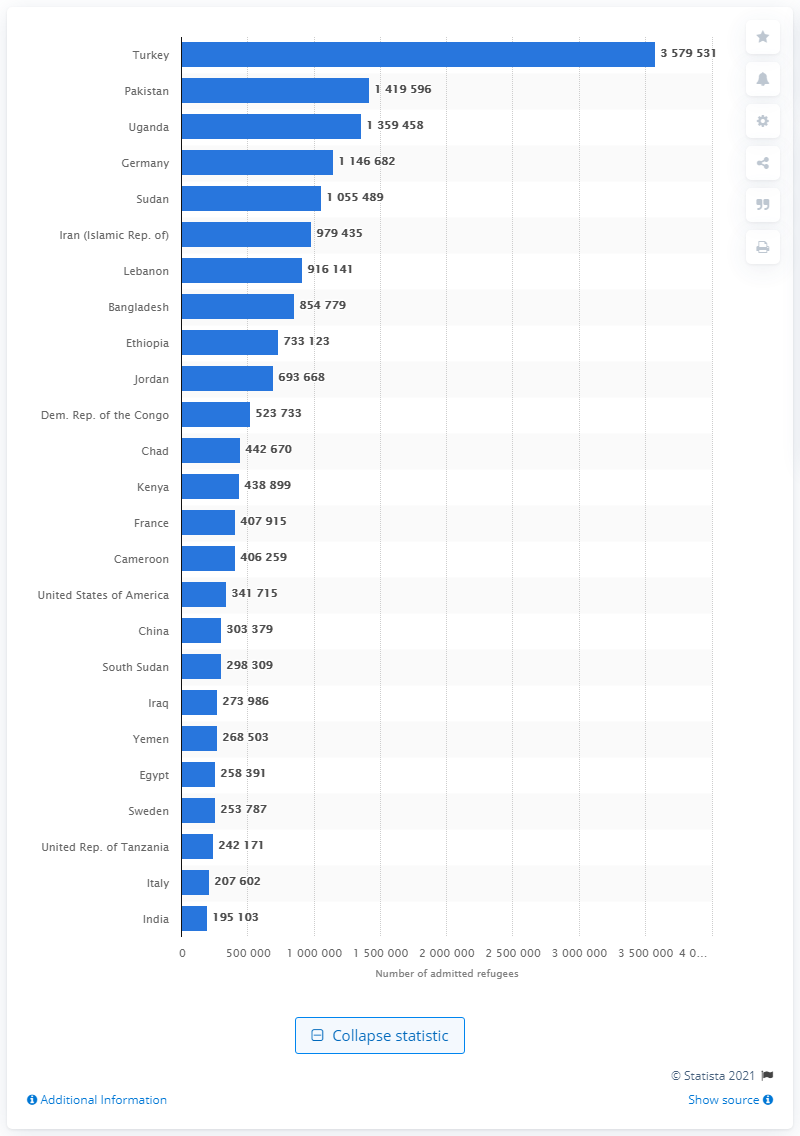Point out several critical features in this image. At the end of 2019, there were approximately 357,9531 refugees living in Turkey. 